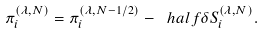Convert formula to latex. <formula><loc_0><loc_0><loc_500><loc_500>\pi _ { i } ^ { ( \lambda , N ) } = \pi _ { i } ^ { ( \lambda , N - 1 / 2 ) } - \ h a l f \delta S _ { i } ^ { ( \lambda , N ) } .</formula> 